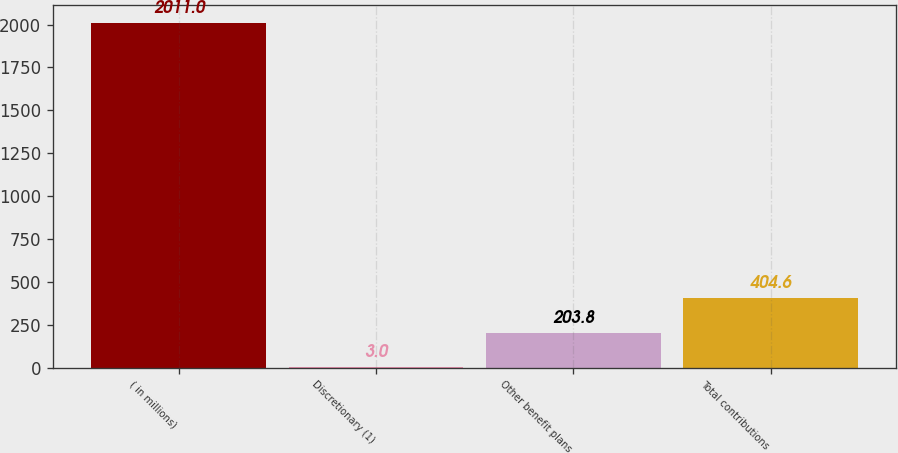<chart> <loc_0><loc_0><loc_500><loc_500><bar_chart><fcel>( in millions)<fcel>Discretionary (1)<fcel>Other benefit plans<fcel>Total contributions<nl><fcel>2011<fcel>3<fcel>203.8<fcel>404.6<nl></chart> 